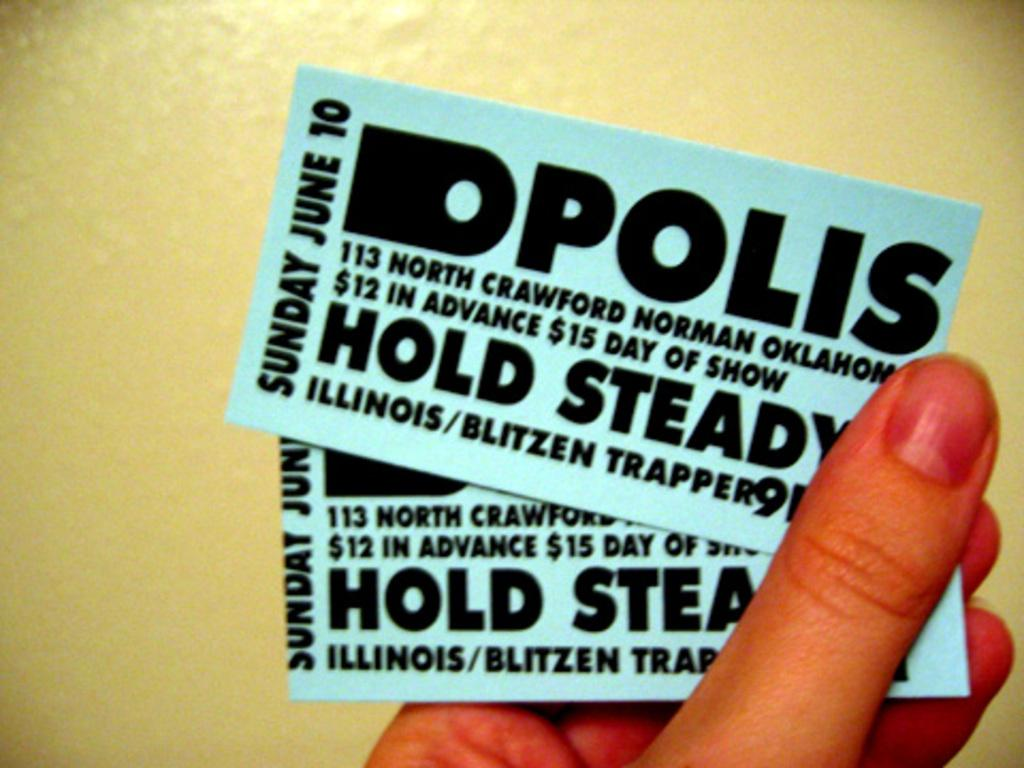What is the person holding in the image? There is a person's hand holding tickets in the image. What can be seen in the background of the image? There is a wall in the background of the image. What type of shoe is visible on the wall in the image? There is no shoe visible on the wall in the image; only a wall is present in the background. 